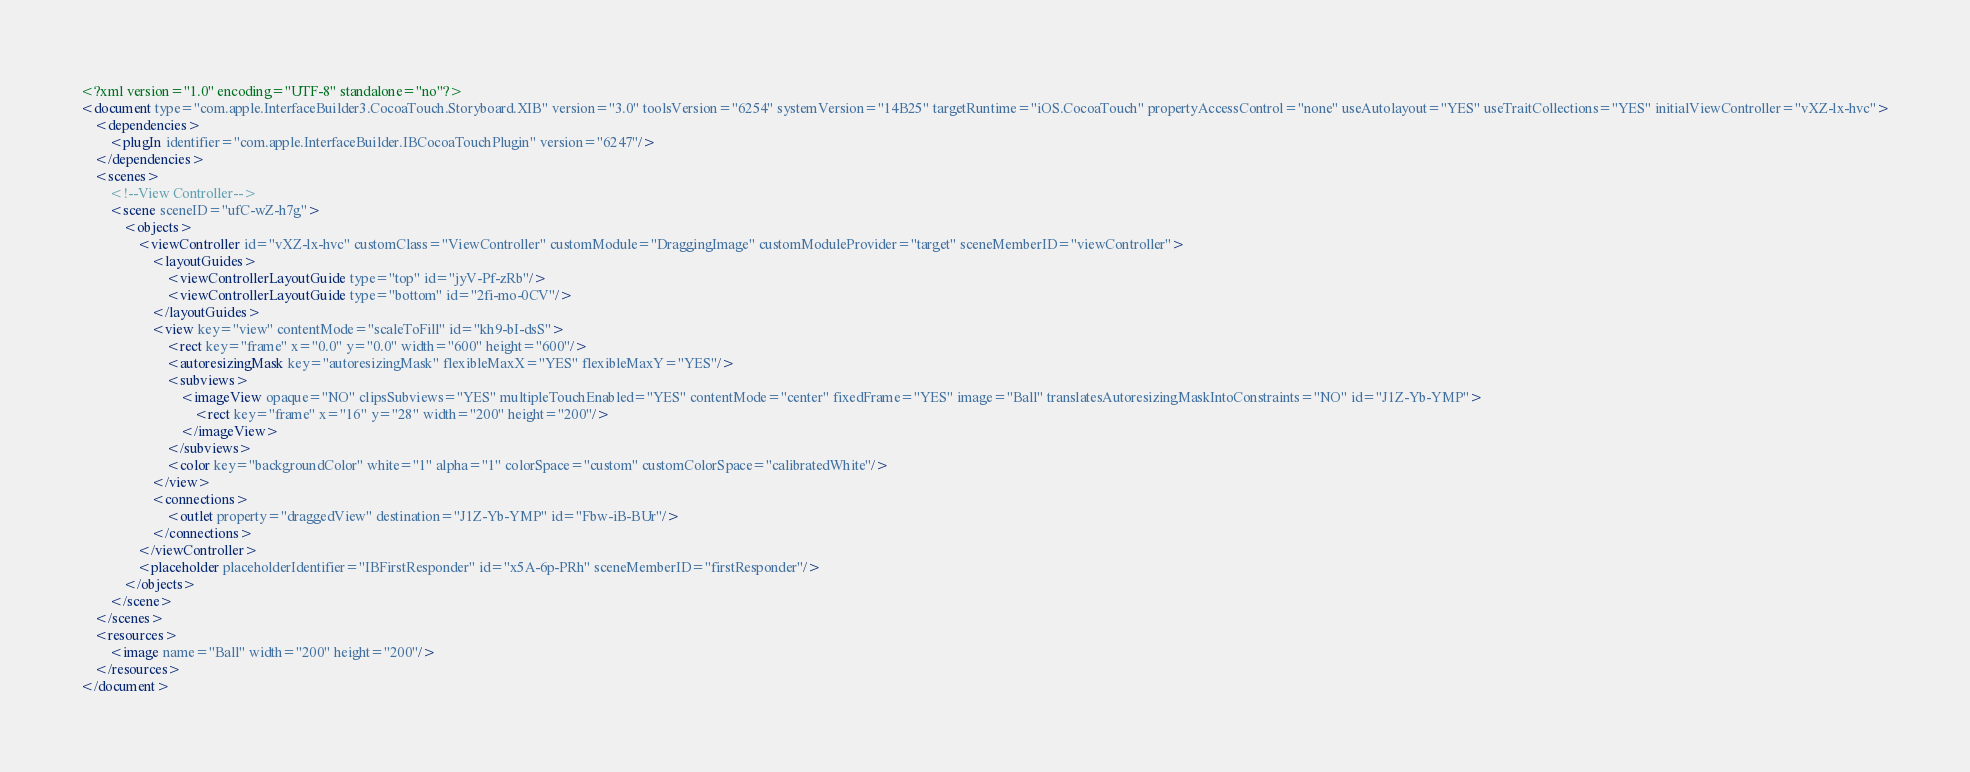<code> <loc_0><loc_0><loc_500><loc_500><_XML_><?xml version="1.0" encoding="UTF-8" standalone="no"?>
<document type="com.apple.InterfaceBuilder3.CocoaTouch.Storyboard.XIB" version="3.0" toolsVersion="6254" systemVersion="14B25" targetRuntime="iOS.CocoaTouch" propertyAccessControl="none" useAutolayout="YES" useTraitCollections="YES" initialViewController="vXZ-lx-hvc">
    <dependencies>
        <plugIn identifier="com.apple.InterfaceBuilder.IBCocoaTouchPlugin" version="6247"/>
    </dependencies>
    <scenes>
        <!--View Controller-->
        <scene sceneID="ufC-wZ-h7g">
            <objects>
                <viewController id="vXZ-lx-hvc" customClass="ViewController" customModule="DraggingImage" customModuleProvider="target" sceneMemberID="viewController">
                    <layoutGuides>
                        <viewControllerLayoutGuide type="top" id="jyV-Pf-zRb"/>
                        <viewControllerLayoutGuide type="bottom" id="2fi-mo-0CV"/>
                    </layoutGuides>
                    <view key="view" contentMode="scaleToFill" id="kh9-bI-dsS">
                        <rect key="frame" x="0.0" y="0.0" width="600" height="600"/>
                        <autoresizingMask key="autoresizingMask" flexibleMaxX="YES" flexibleMaxY="YES"/>
                        <subviews>
                            <imageView opaque="NO" clipsSubviews="YES" multipleTouchEnabled="YES" contentMode="center" fixedFrame="YES" image="Ball" translatesAutoresizingMaskIntoConstraints="NO" id="J1Z-Yb-YMP">
                                <rect key="frame" x="16" y="28" width="200" height="200"/>
                            </imageView>
                        </subviews>
                        <color key="backgroundColor" white="1" alpha="1" colorSpace="custom" customColorSpace="calibratedWhite"/>
                    </view>
                    <connections>
                        <outlet property="draggedView" destination="J1Z-Yb-YMP" id="Fbw-iB-BUr"/>
                    </connections>
                </viewController>
                <placeholder placeholderIdentifier="IBFirstResponder" id="x5A-6p-PRh" sceneMemberID="firstResponder"/>
            </objects>
        </scene>
    </scenes>
    <resources>
        <image name="Ball" width="200" height="200"/>
    </resources>
</document>
</code> 